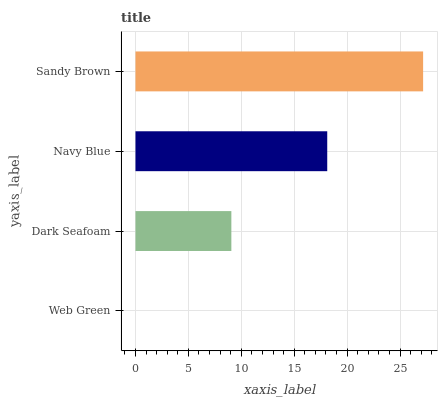Is Web Green the minimum?
Answer yes or no. Yes. Is Sandy Brown the maximum?
Answer yes or no. Yes. Is Dark Seafoam the minimum?
Answer yes or no. No. Is Dark Seafoam the maximum?
Answer yes or no. No. Is Dark Seafoam greater than Web Green?
Answer yes or no. Yes. Is Web Green less than Dark Seafoam?
Answer yes or no. Yes. Is Web Green greater than Dark Seafoam?
Answer yes or no. No. Is Dark Seafoam less than Web Green?
Answer yes or no. No. Is Navy Blue the high median?
Answer yes or no. Yes. Is Dark Seafoam the low median?
Answer yes or no. Yes. Is Web Green the high median?
Answer yes or no. No. Is Sandy Brown the low median?
Answer yes or no. No. 